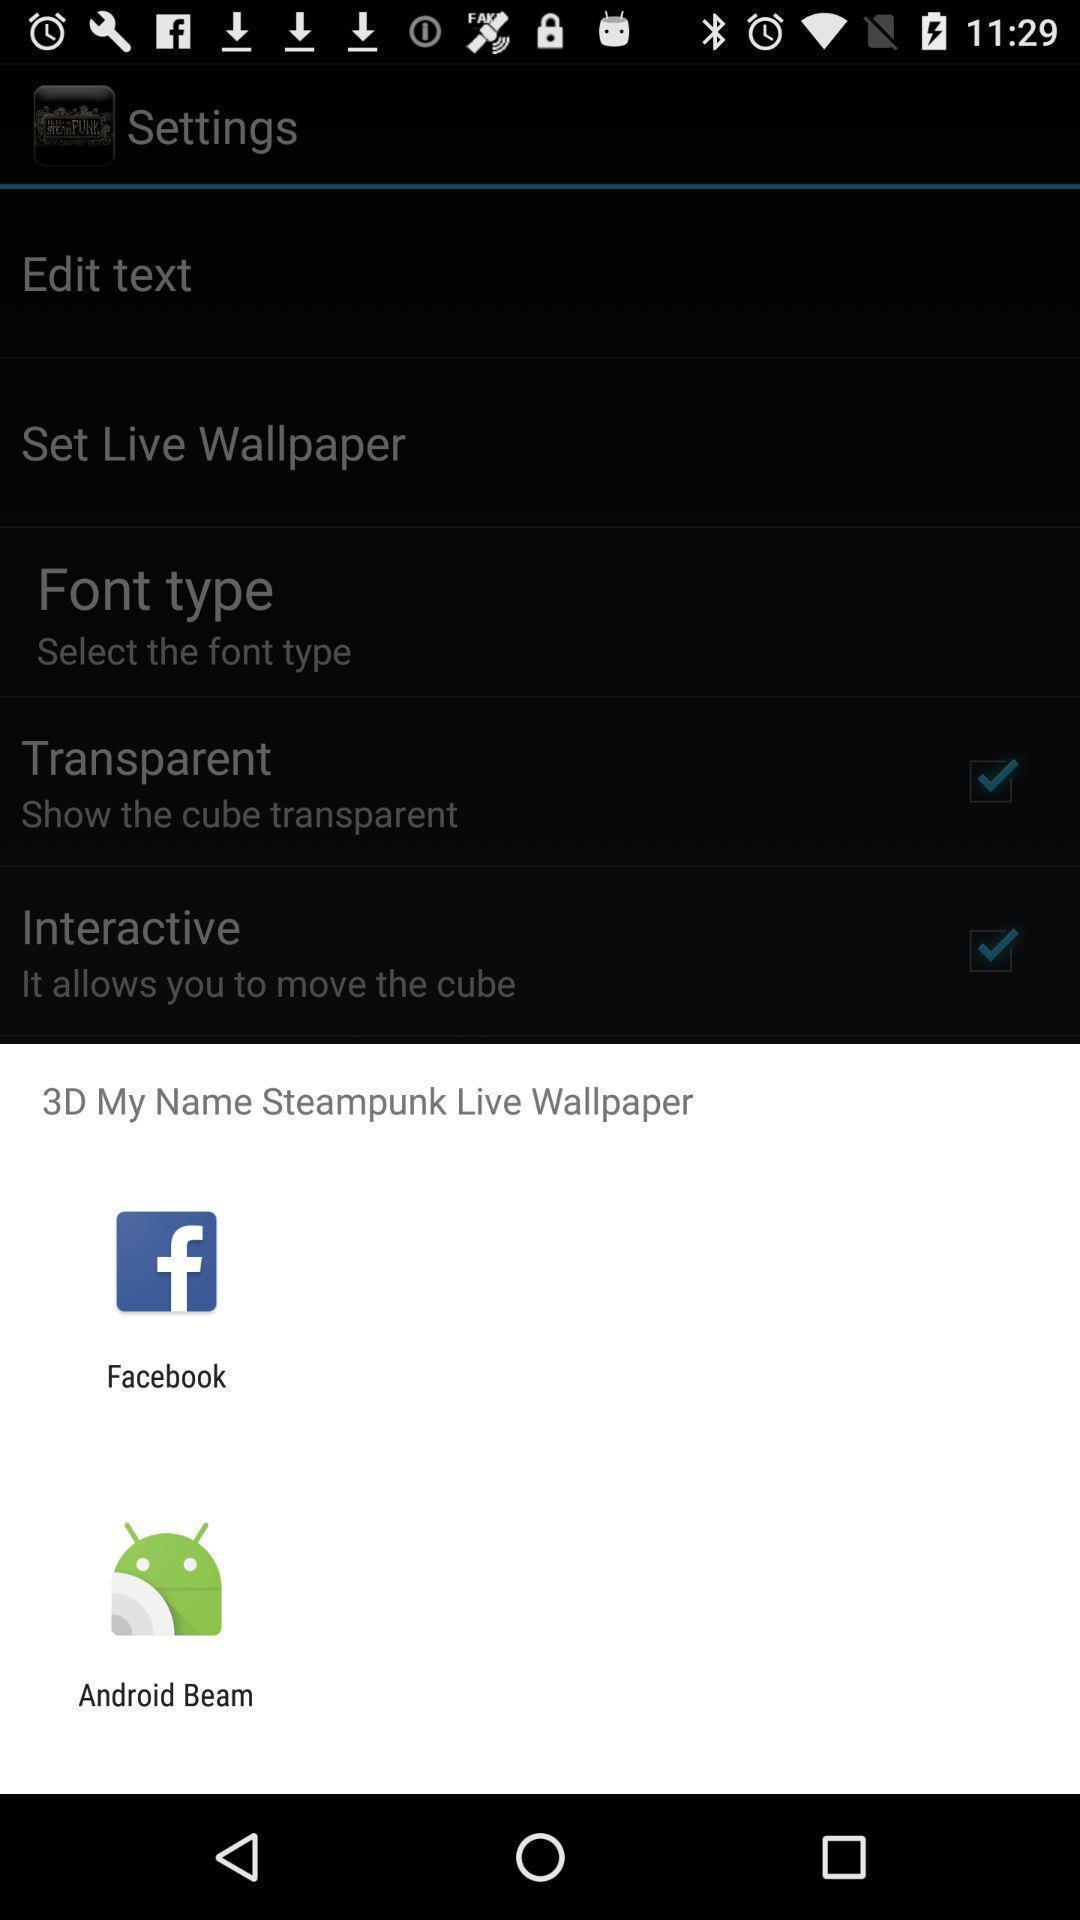Describe the content in this image. Popup showing different apps to select. 